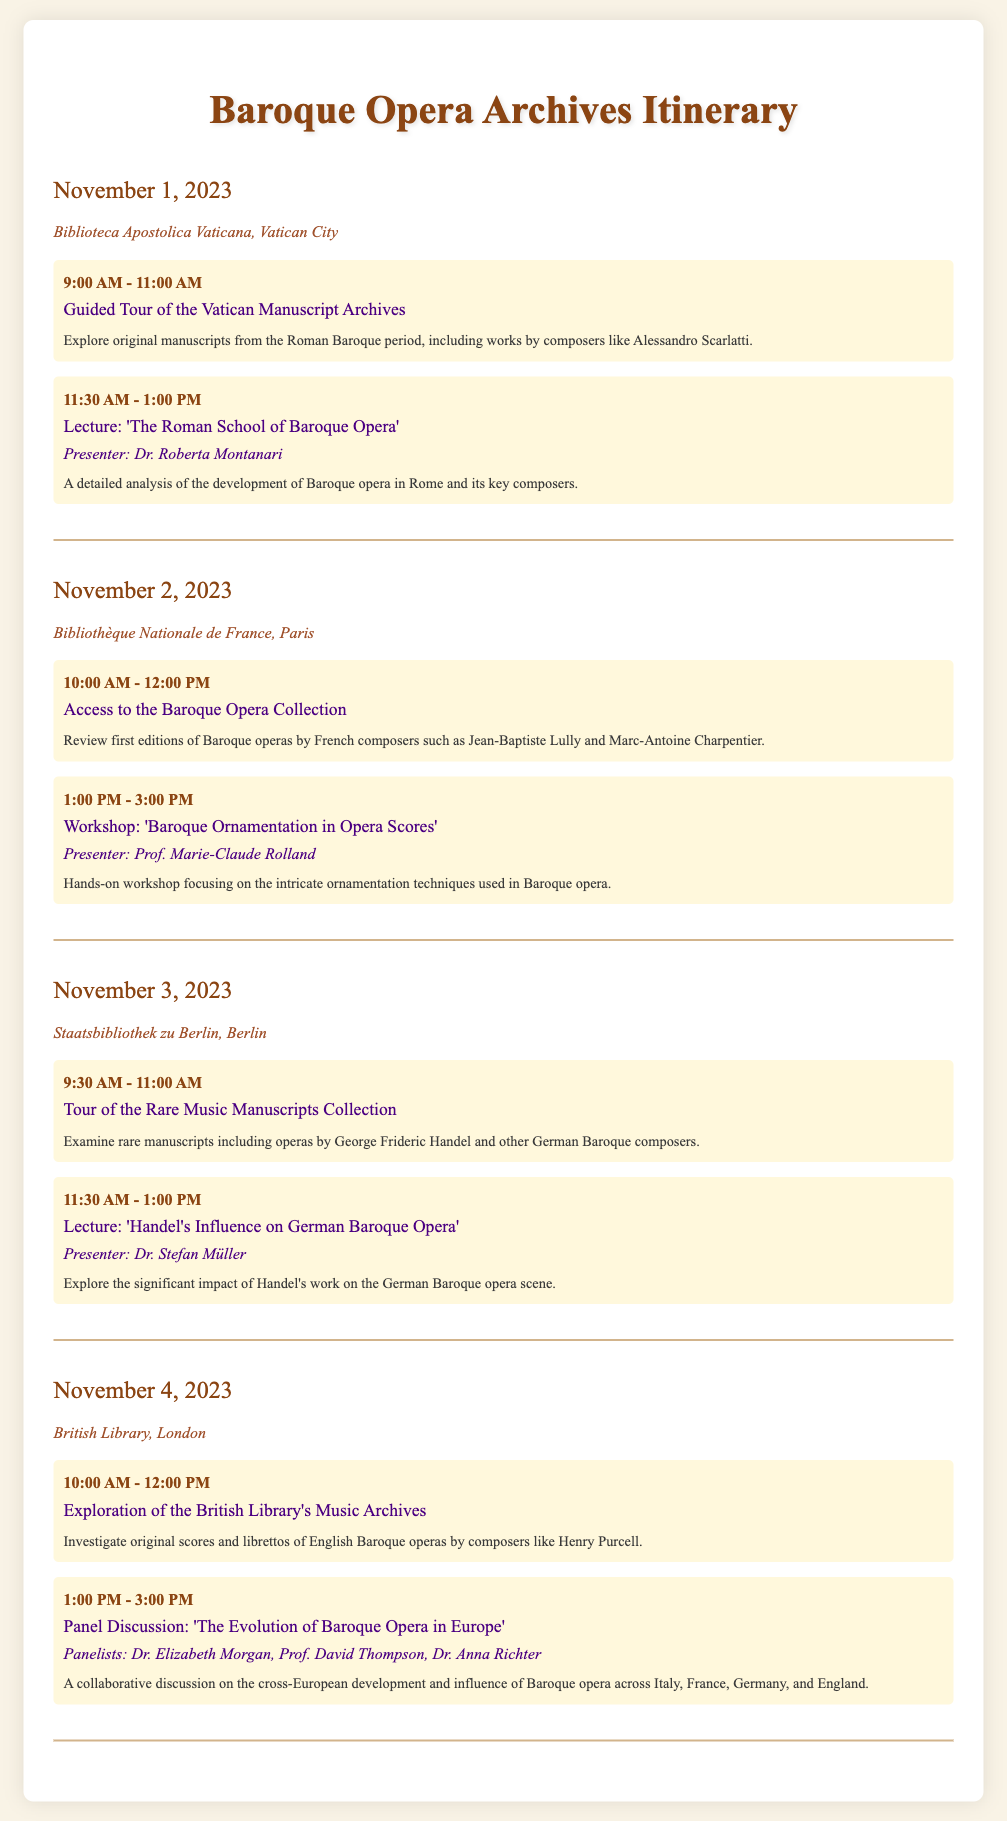What is the date of the guided tour? The guided tour is scheduled for November 1, 2023, as mentioned in the first day’s itinerary.
Answer: November 1, 2023 Who is the presenter of the lecture on the Roman School of Baroque Opera? The presenter for this lecture is Dr. Roberta Montanari, as noted under the related activity.
Answer: Dr. Roberta Montanari What location hosts the workshop on Baroque Ornamentation? The workshop is held at the Bibliothèque Nationale de France, as indicated in the itinerary for November 2, 2023.
Answer: Bibliothèque Nationale de France Which composers' works can be reviewed at the Baroque Opera Collection? The operas by French composers such as Jean-Baptiste Lully and Marc-Antoine Charpentier are reviewed during the activity.
Answer: Jean-Baptiste Lully and Marc-Antoine Charpentier What time does the panel discussion on the evolution of Baroque Opera start? The panel discussion is scheduled to start at 1:00 PM on November 4, 2023.
Answer: 1:00 PM How many activities are scheduled on November 3, 2023? There are two activities listed for November 3, 2023: a tour and a lecture.
Answer: Two Which library is associated with George Frideric Handel's manuscripts? The Staatsbibliothek zu Berlin is linked to Handel's manuscripts as per the itinerary for November 3, 2023.
Answer: Staatsbibliothek zu Berlin Name a baroque opera composer mentioned in the British Library activities. Henry Purcell is specifically mentioned under the exploration of the British Library's music archives.
Answer: Henry Purcell 